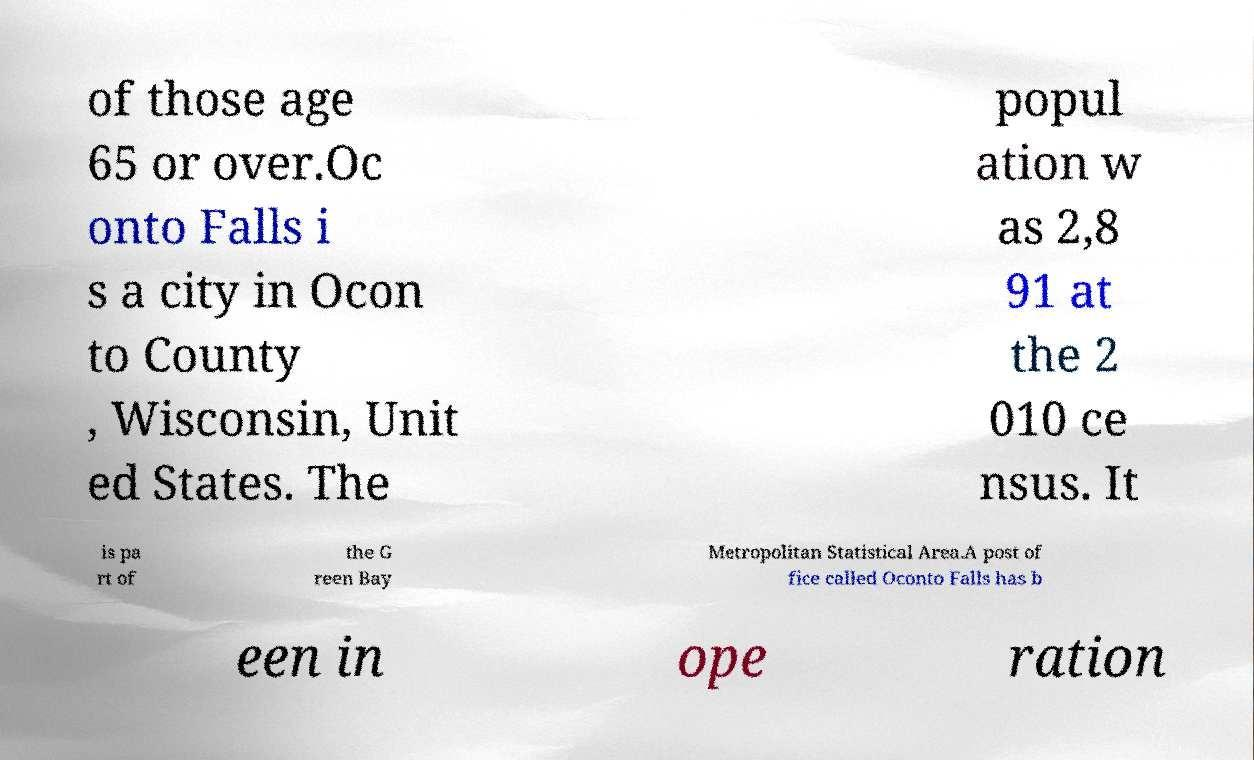Could you assist in decoding the text presented in this image and type it out clearly? of those age 65 or over.Oc onto Falls i s a city in Ocon to County , Wisconsin, Unit ed States. The popul ation w as 2,8 91 at the 2 010 ce nsus. It is pa rt of the G reen Bay Metropolitan Statistical Area.A post of fice called Oconto Falls has b een in ope ration 